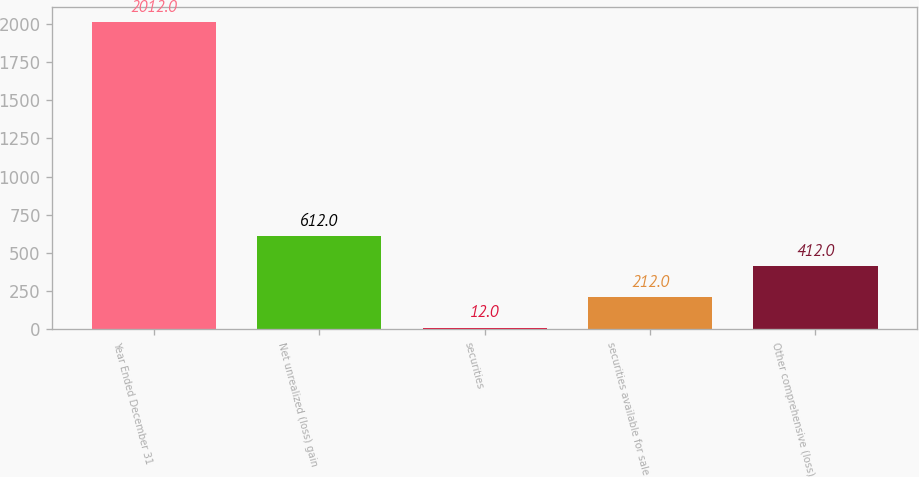Convert chart to OTSL. <chart><loc_0><loc_0><loc_500><loc_500><bar_chart><fcel>Year Ended December 31<fcel>Net unrealized (loss) gain<fcel>securities<fcel>securities available for sale<fcel>Other comprehensive (loss)<nl><fcel>2012<fcel>612<fcel>12<fcel>212<fcel>412<nl></chart> 